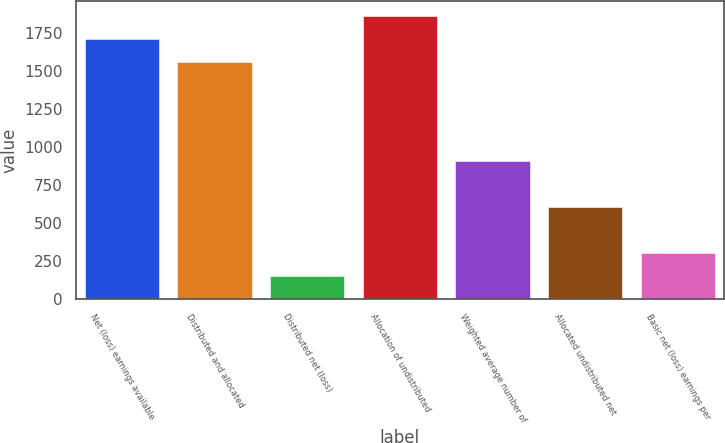Convert chart to OTSL. <chart><loc_0><loc_0><loc_500><loc_500><bar_chart><fcel>Net (loss) earnings available<fcel>Distributed and allocated<fcel>Distributed net (loss)<fcel>Allocation of undistributed<fcel>Weighted average number of<fcel>Allocated undistributed net<fcel>Basic net (loss) earnings per<nl><fcel>1712.44<fcel>1561.37<fcel>151.57<fcel>1863.51<fcel>906.92<fcel>604.78<fcel>302.64<nl></chart> 